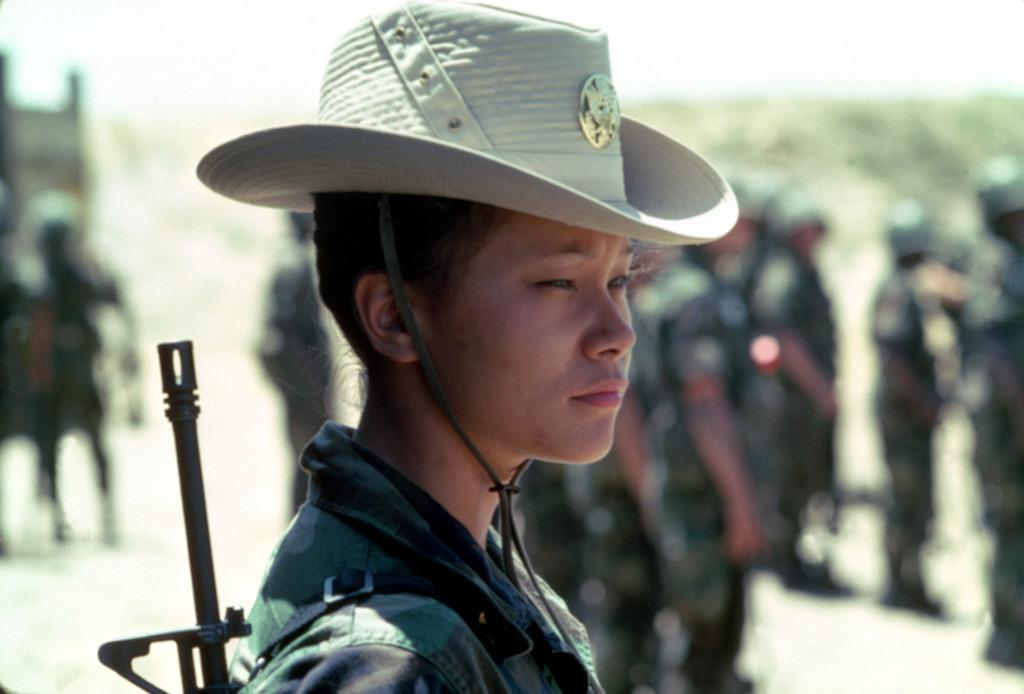How many people are in the image? There are people in the image, but the exact number is not specified. Can you describe any specific clothing item worn by one of the people? Yes, one person is wearing a hat. What can be observed about the background of the image? The background of the image is blurred. What type of value can be seen on the island in the image? There is no island present in the image, so it is not possible to determine if there is any value on it. 